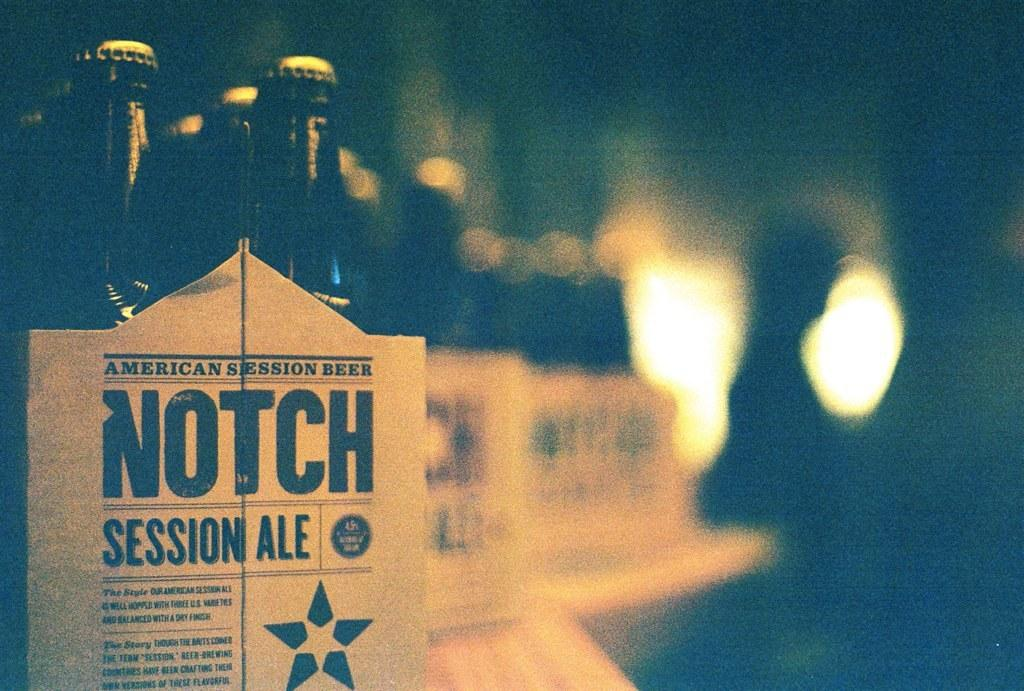<image>
Describe the image concisely. some bottles with the word notch in it 